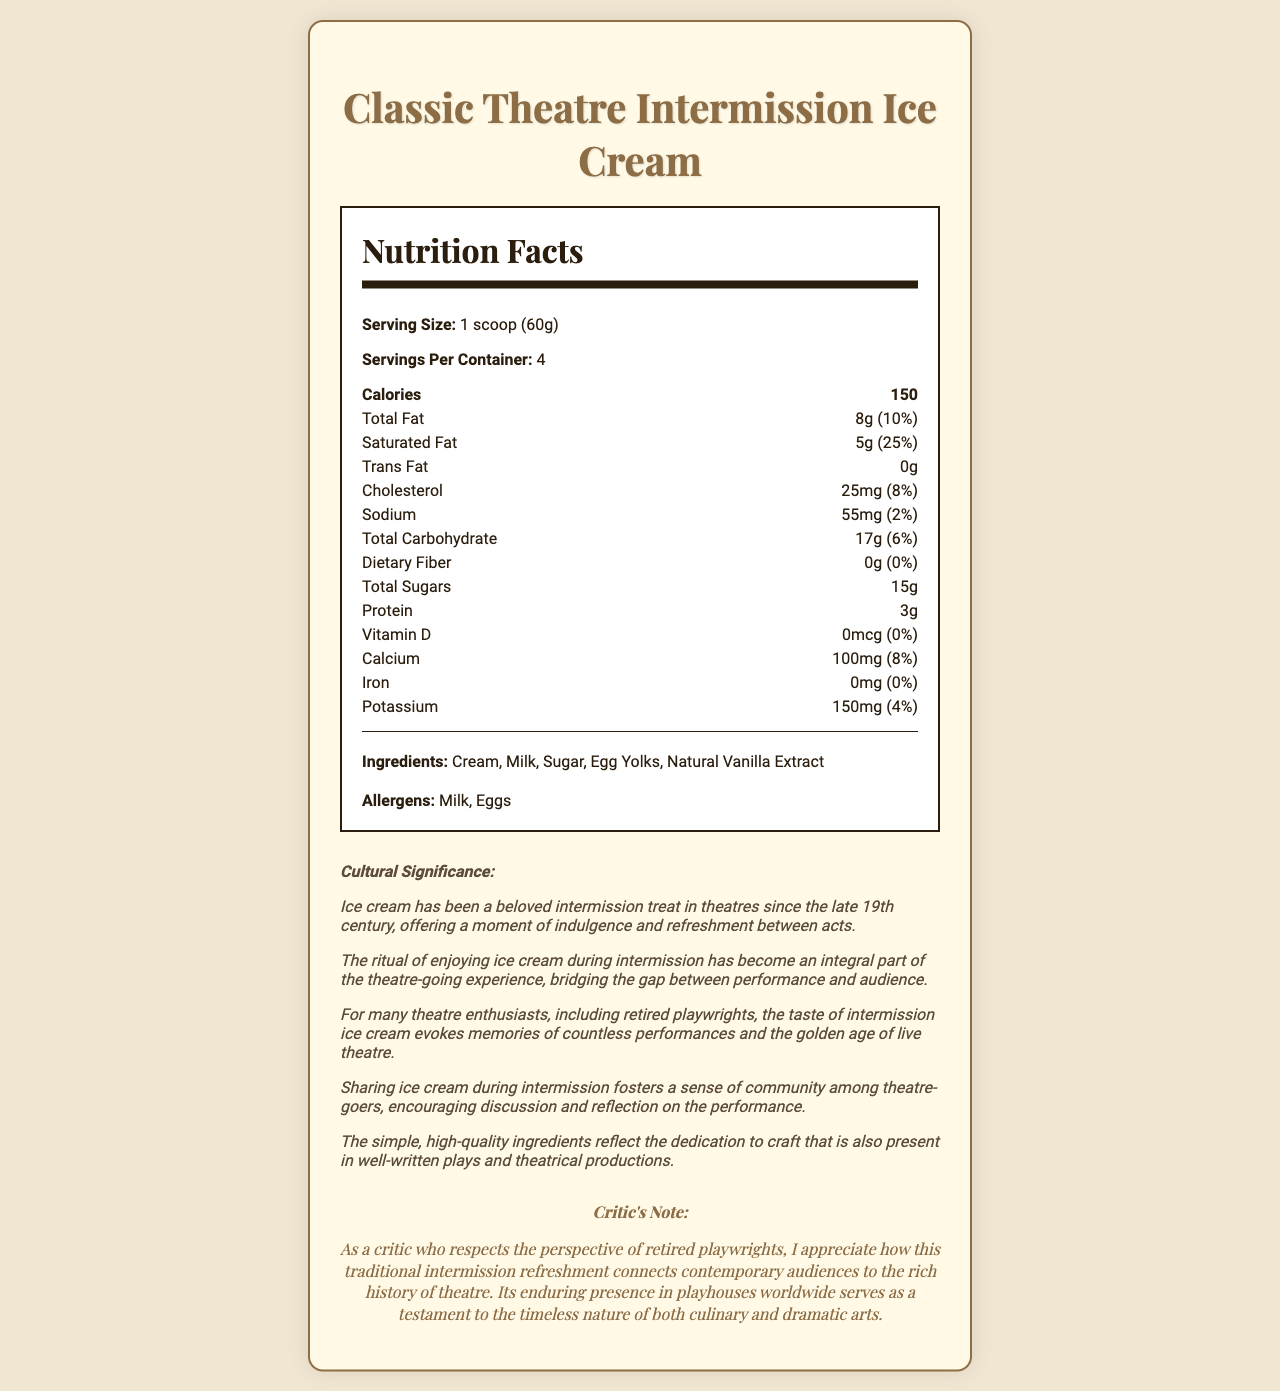what is the serving size of the Classic Theatre Intermission Ice Cream? The serving size is clearly listed as "1 scoop (60g)" in the nutrition facts section of the document.
Answer: 1 scoop (60g) how many servings are in one container? The document specifies that there are "4" servings per container.
Answer: 4 how many calories are there per serving? Each serving contains "150" calories, as listed under the nutrition facts.
Answer: 150 list the main ingredients of the ice cream. The ingredients section of the document lists these as the main components of the ice cream.
Answer: Cream, Milk, Sugar, Egg Yolks, Natural Vanilla Extract name the allergens present in the product. The allergens section of the document indicates that the product contains "Milk" and "Eggs."
Answer: Milk, Eggs how much saturated fat does each serving contain? Each serving contains "5g" of saturated fat, as stated in the nutrition facts.
Answer: 5g how much calcium is present per serving, and what percent of the daily value does this represent? Each serving contains "100mg" of calcium, which is "8%" of the daily value.
Answer: 100mg, 8% how much protein does one serving of the ice cream provide? The document specifies that one serving provides "3g" of protein.
Answer: 3g what is the amount of dietary fiber in each serving? According to the nutrition facts, each serving contains "0g" of dietary fiber.
Answer: 0g does the ice cream contain any added vitamin D? The nutrition facts indicate "0mcg" of Vitamin D, implying there is no added vitamin D.
Answer: No what is the cultural significance of enjoying ice cream during intermission? The document explains that enjoying ice cream during intermission is a tradition dating back to the late 19th century and highlights its roles in nostalgia, community, and craftsmanship.
Answer: Ice cream has been enjoyed in theaters since the late 19th century, providing a beloved treat and fostering a sense of community among theater-goers. what is the total fat content in one serving? The total fat content in one serving is "8g," as listed in the nutrition facts.
Answer: 8g how does the ice cream’s craftsmanship reflect the dedication seen in well-written plays and theatrical productions? The document notes that the ice cream's high-quality ingredients demonstrate the same commitment to craft as in theatrical productions.
Answer: The use of simple, high-quality ingredients reflects the dedication to craftsmanship, similar to that in well-written plays. which nutrient has the highest daily value percentage? A. Cholesterol B. Saturated Fat C. Potassium D. Calcium Saturated fat has the highest daily value percentage at "25%."
Answer: B. Saturated Fat how many total sugars are there per serving? A. 10g B. 12g C. 15g D. 20g The total sugars per serving are listed as "15g."
Answer: C. 15g does this ice cream have any trans fat? The nutrition facts indicate "0g" of trans fat per serving.
Answer: No How would you summarize the document? The summary captures the essential points of the document, including its nutritional details, cultural significance, and a critic's perspective.
Answer: The document provides detailed nutritional information for Classic Theatre Intermission Ice Cream, highlighting serving size, calories, fat content, ingredients, and allergens. Additionally, it explains the cultural significance and tradition of enjoying ice cream during theatre intermissions and includes a critic's note emphasizing the connection between culinary and dramatic arts. in what ways does enjoying ice cream during intermission foster a sense of community among theatre-goers? The document explains that the social aspect of sharing ice cream promotes engagement and connection among the audience.
Answer: Sharing ice cream during intermission encourages discussion and reflection on the performance, fostering a sense of community. what is the cholesterol content per serving, and its daily value percentage? Each serving contains "25mg" of cholesterol, representing "8%" of the daily value.
Answer: 25mg, 8% what is the total carbohydrate content in one serving? The document states that the total carbohydrate content in one serving is "17g."
Answer: 17g did this ice cream contain any artificial flavoring? The ingredients list includes natural vanilla extract but does not specify whether there are any artificial flavorings.
Answer: Not mentioned what is the critic's perspective on the connection between the ice cream and theatre? The critic's note indicates a respect for how the ice cream enhances the theater-going experience by bridging historical and modern traditions.
Answer: The critic appreciates the ice cream's ability to connect contemporary audiences to the rich history of theatre, noting the timeless nature of both culinary and dramatic arts. what is sodium's daily value percentage per serving? According to the nutrition facts, sodium has a daily value of "2%" per serving.
Answer: 2% what kind of ice cream is enjoyed as a traditional intermission refreshment in theatres? The document specifically refers to the "Classic Theatre Intermission Ice Cream" as the traditional refreshment.
Answer: Classic Theatre Intermission Ice Cream 